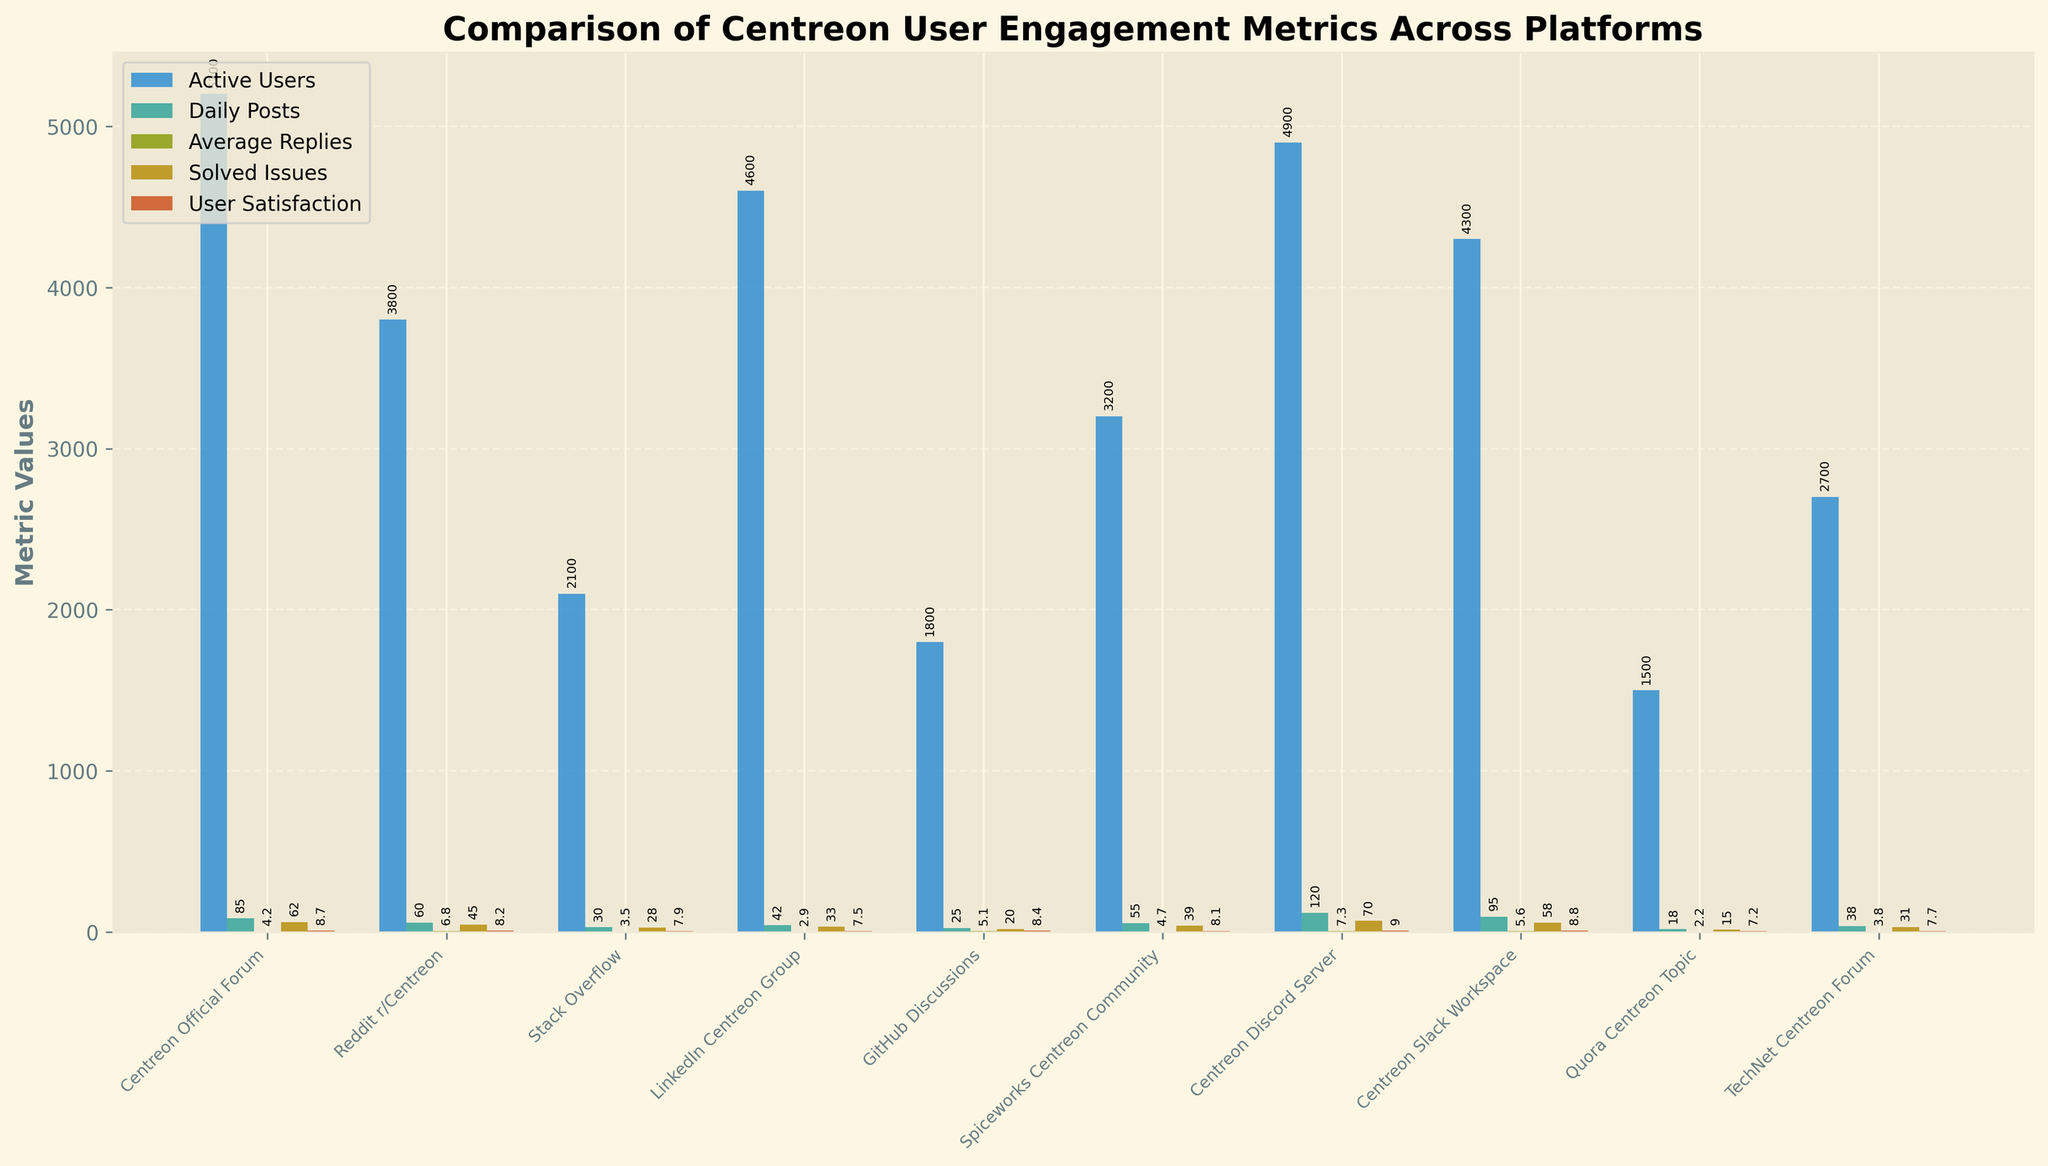Which platform has the most active users? The tallest bar in the 'Active Users' metric represents the platform with the most active users.
Answer: Centreon Official Forum Which platform has the highest user satisfaction? Look for the tallest bar in the 'User Satisfaction' metric to find the platform with the highest user satisfaction score.
Answer: Centreon Discord Server Which platform has the least number of solved issues? Identify the shortest bar in the 'Solved Issues' metric to find the platform with the least number of solved issues.
Answer: Quora Centreon Topic What is the sum of active users in GitHub Discussions and Quora Centreon Topic? Add the values from the 'Active Users' bars for both GitHub Discussions and Quora Centreon Topic (1800 + 1500).
Answer: 3300 Compare the average number of replies between Centreon Slack Workspace and Reddit r/Centreon. Which one is higher? Look at the heights of the bars under 'Average Replies' for both Centreon Slack Workspace and Reddit r/Centreon.
Answer: Reddit r/Centreon On which platform do users post most frequently on a daily basis? Find the tallest bar in the 'Daily Posts' metric.
Answer: Centreon Discord Server What is the difference in user satisfaction between the Centreon Official Forum and LinkedIn Centreon Group? Subtract the user satisfaction score of LinkedIn Centreon Group (7.5) from that of Centreon Official Forum (8.7).
Answer: 1.2 How many platforms have a user satisfaction score of 8.0 or higher? Count the number of bars in the 'User Satisfaction' metric that reach or exceed the value of 8.0.
Answer: 6 What is the average number of daily posts across all platforms? Sum the number of 'Daily Posts' for all platforms and divide by the number of platforms ((85 + 60 + 30 + 42 + 25 + 55 + 120 + 95 + 18 + 38) / 10).
Answer: 56.8 Compare the Centreon Official Forum and Stack Overflow in terms of solved issues. What is the ratio of solved issues between the two platforms? Determine the number of solved issues for both platforms (62 for Centreon Official Forum and 28 for Stack Overflow), then calculate the ratio (62/28).
Answer: ~2.21 